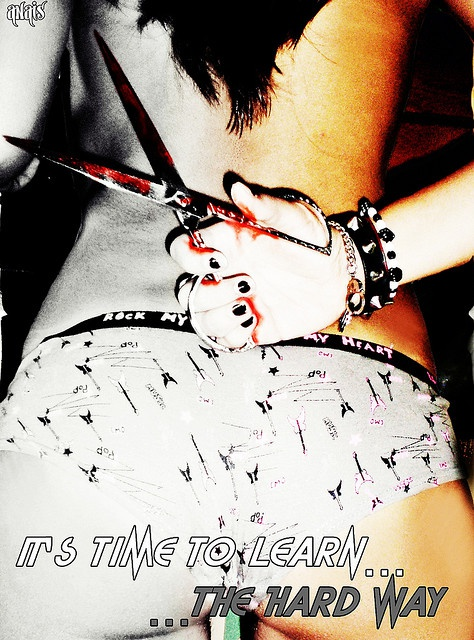Describe the objects in this image and their specific colors. I can see people in white, lightgray, black, tan, and darkgray tones, people in lightgray, white, black, tan, and orange tones, and scissors in lightgray, black, white, maroon, and brown tones in this image. 